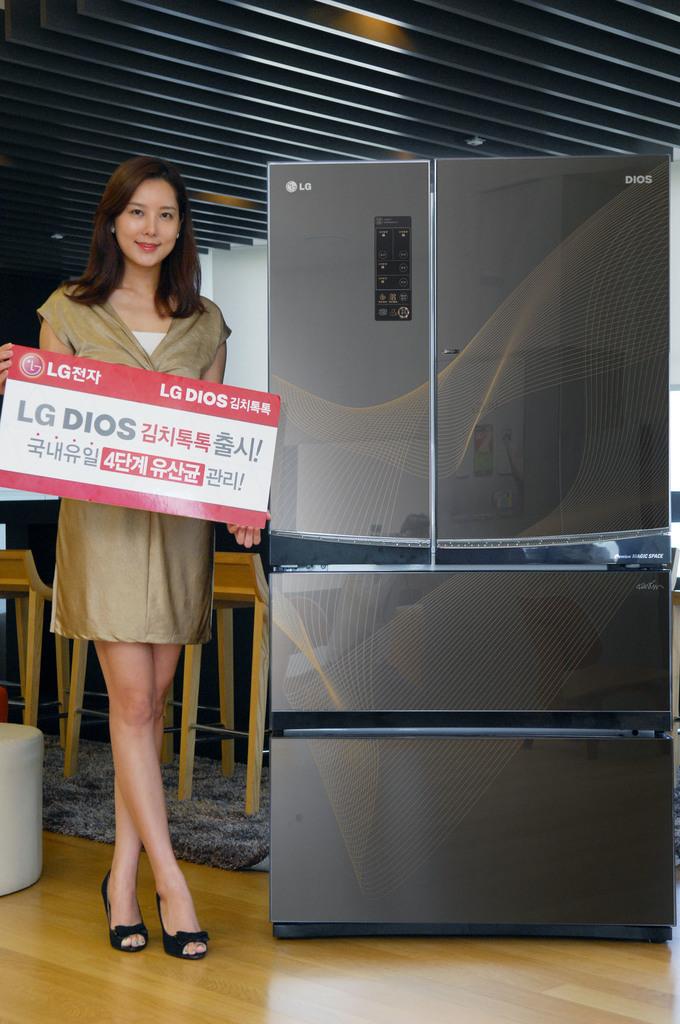What brand is this refrigerator?
Give a very brief answer. Lg. 